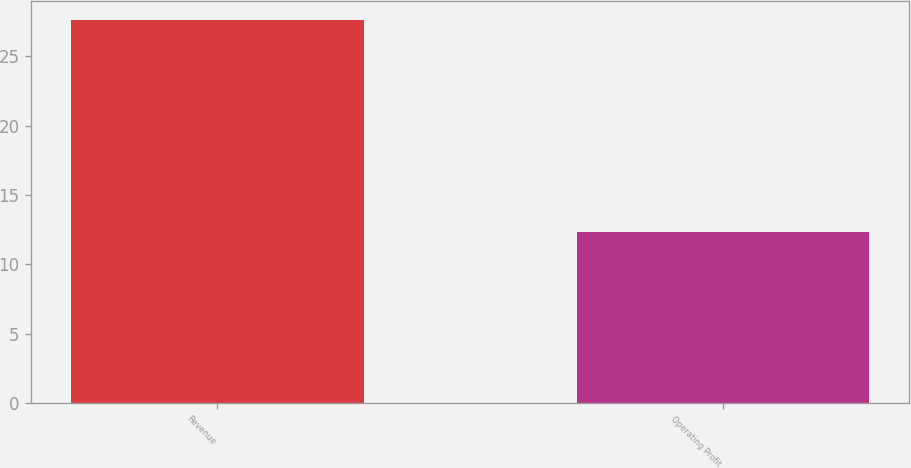<chart> <loc_0><loc_0><loc_500><loc_500><bar_chart><fcel>Revenue<fcel>Operating Profit<nl><fcel>27.6<fcel>12.3<nl></chart> 